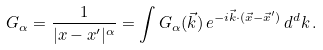<formula> <loc_0><loc_0><loc_500><loc_500>G _ { \alpha } = \frac { 1 } { | x - x ^ { \prime } | ^ { \alpha } } = \int G _ { \alpha } ( \vec { k } ) \, e ^ { - i \vec { k } \cdot ( \vec { x } - \vec { x } ^ { \prime } ) } \, d ^ { d } k \, .</formula> 